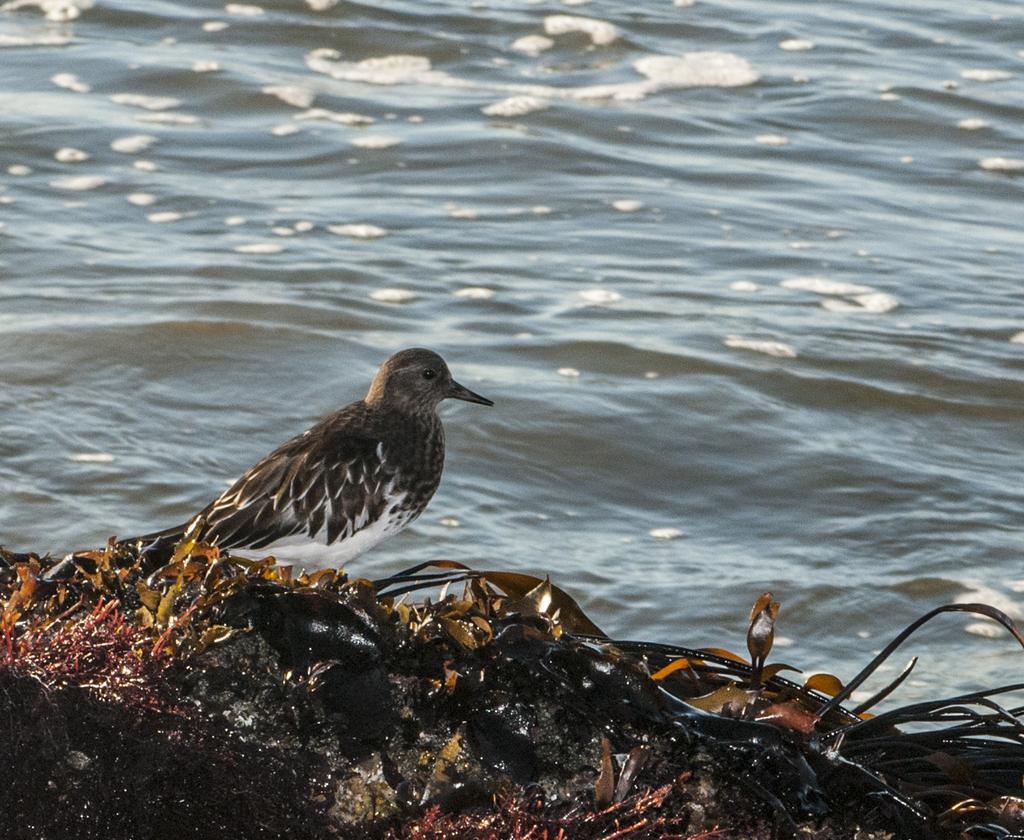Describe this image in one or two sentences. In the image there is a bird standing on the leaves in the foreground and behind the bird there is a water surface. 